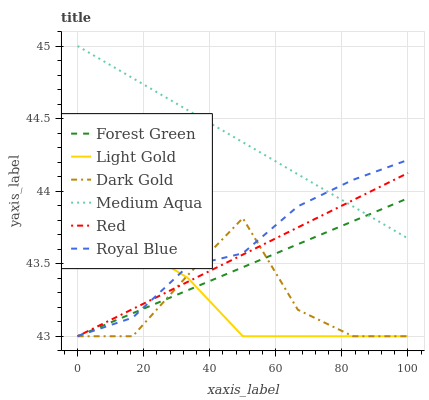Does Light Gold have the minimum area under the curve?
Answer yes or no. Yes. Does Medium Aqua have the maximum area under the curve?
Answer yes or no. Yes. Does Royal Blue have the minimum area under the curve?
Answer yes or no. No. Does Royal Blue have the maximum area under the curve?
Answer yes or no. No. Is Medium Aqua the smoothest?
Answer yes or no. Yes. Is Dark Gold the roughest?
Answer yes or no. Yes. Is Royal Blue the smoothest?
Answer yes or no. No. Is Royal Blue the roughest?
Answer yes or no. No. Does Dark Gold have the lowest value?
Answer yes or no. Yes. Does Royal Blue have the lowest value?
Answer yes or no. No. Does Medium Aqua have the highest value?
Answer yes or no. Yes. Does Royal Blue have the highest value?
Answer yes or no. No. Is Dark Gold less than Medium Aqua?
Answer yes or no. Yes. Is Medium Aqua greater than Dark Gold?
Answer yes or no. Yes. Does Royal Blue intersect Red?
Answer yes or no. Yes. Is Royal Blue less than Red?
Answer yes or no. No. Is Royal Blue greater than Red?
Answer yes or no. No. Does Dark Gold intersect Medium Aqua?
Answer yes or no. No. 